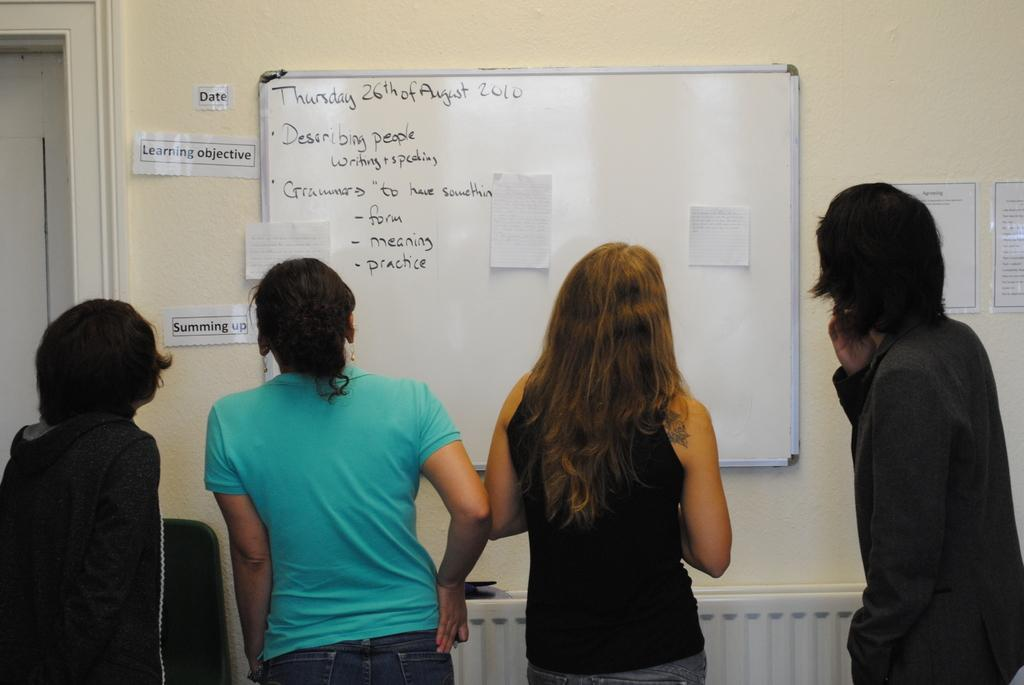Provide a one-sentence caption for the provided image. A group of people looking at a white board on August 26. 